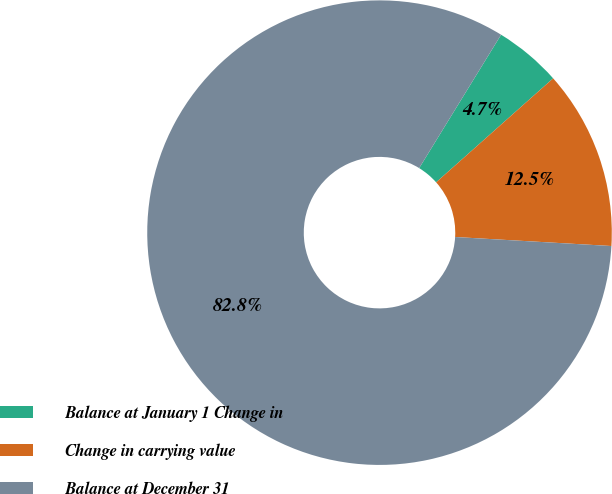Convert chart. <chart><loc_0><loc_0><loc_500><loc_500><pie_chart><fcel>Balance at January 1 Change in<fcel>Change in carrying value<fcel>Balance at December 31<nl><fcel>4.67%<fcel>12.48%<fcel>82.85%<nl></chart> 